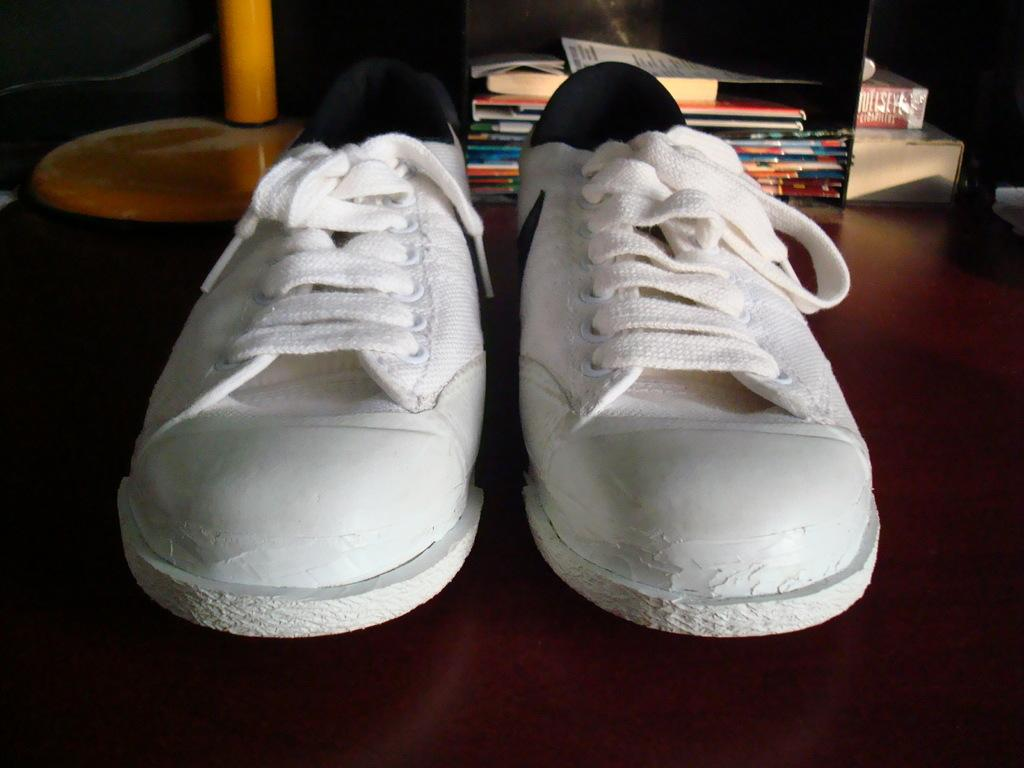What type of footwear is visible in the image? There is a pair of shoes in the image. What color are the shoes? The shoes are white in color. What can be seen in the background of the image? There are books and other objects in the background of the image. What grade does the tooth receive in the image? There is no tooth present in the image, so it is not possible to determine a grade for it. 